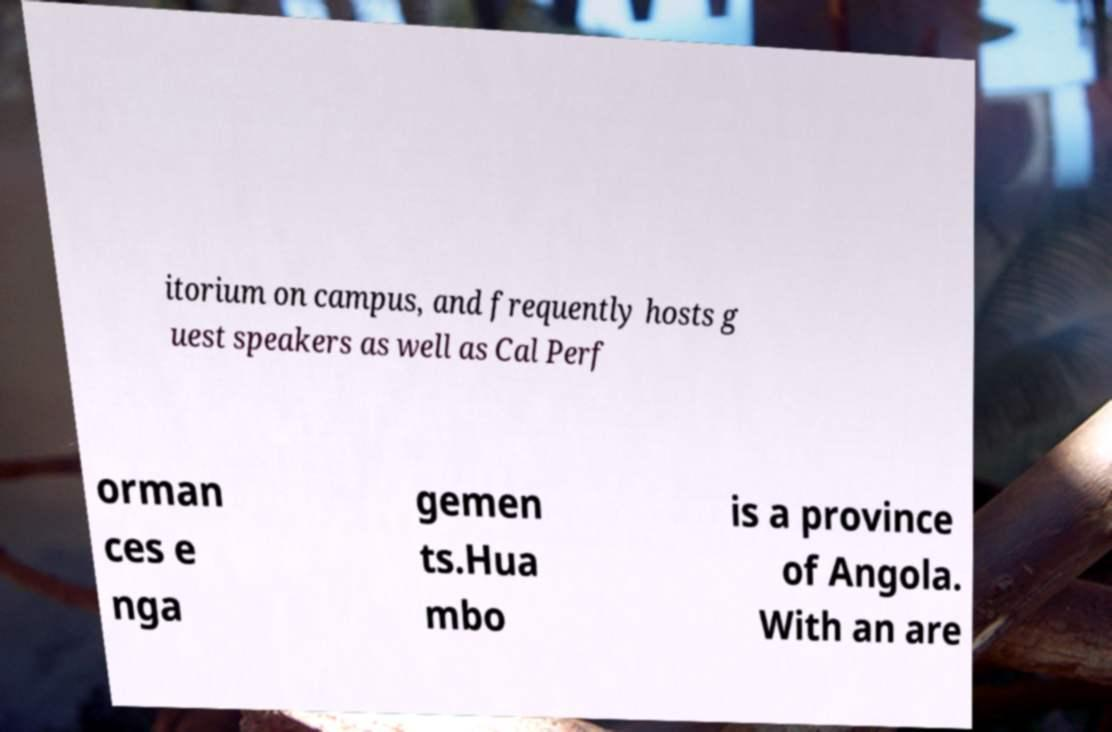Could you extract and type out the text from this image? itorium on campus, and frequently hosts g uest speakers as well as Cal Perf orman ces e nga gemen ts.Hua mbo is a province of Angola. With an are 